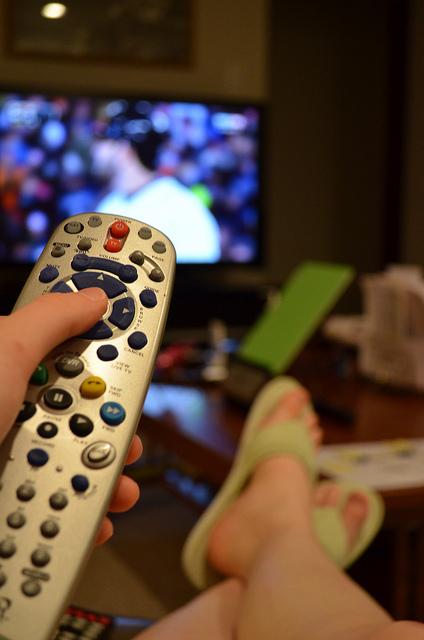Is someone just relaxing?
Write a very short answer. Yes. What is the person holding?
Write a very short answer. Remote. What style of shoes are these?
Keep it brief. Flip flops. 